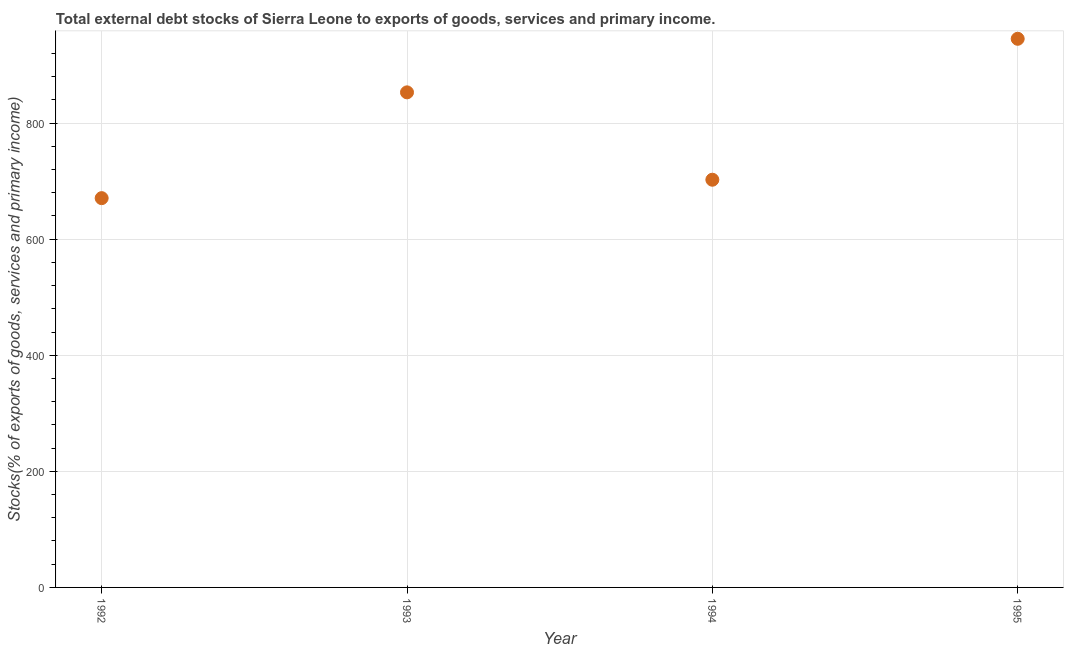What is the external debt stocks in 1994?
Your response must be concise. 702.4. Across all years, what is the maximum external debt stocks?
Your answer should be very brief. 945.21. Across all years, what is the minimum external debt stocks?
Offer a very short reply. 670.67. In which year was the external debt stocks minimum?
Ensure brevity in your answer.  1992. What is the sum of the external debt stocks?
Make the answer very short. 3171.21. What is the difference between the external debt stocks in 1993 and 1995?
Your answer should be compact. -92.28. What is the average external debt stocks per year?
Provide a succinct answer. 792.8. What is the median external debt stocks?
Offer a terse response. 777.66. In how many years, is the external debt stocks greater than 40 %?
Offer a very short reply. 4. Do a majority of the years between 1992 and 1994 (inclusive) have external debt stocks greater than 520 %?
Ensure brevity in your answer.  Yes. What is the ratio of the external debt stocks in 1993 to that in 1994?
Provide a short and direct response. 1.21. Is the difference between the external debt stocks in 1994 and 1995 greater than the difference between any two years?
Your answer should be compact. No. What is the difference between the highest and the second highest external debt stocks?
Provide a short and direct response. 92.28. Is the sum of the external debt stocks in 1992 and 1993 greater than the maximum external debt stocks across all years?
Make the answer very short. Yes. What is the difference between the highest and the lowest external debt stocks?
Your response must be concise. 274.54. In how many years, is the external debt stocks greater than the average external debt stocks taken over all years?
Offer a very short reply. 2. Does the external debt stocks monotonically increase over the years?
Offer a terse response. No. How many dotlines are there?
Provide a succinct answer. 1. What is the difference between two consecutive major ticks on the Y-axis?
Offer a terse response. 200. Does the graph contain any zero values?
Offer a very short reply. No. What is the title of the graph?
Offer a terse response. Total external debt stocks of Sierra Leone to exports of goods, services and primary income. What is the label or title of the X-axis?
Offer a terse response. Year. What is the label or title of the Y-axis?
Provide a short and direct response. Stocks(% of exports of goods, services and primary income). What is the Stocks(% of exports of goods, services and primary income) in 1992?
Your answer should be compact. 670.67. What is the Stocks(% of exports of goods, services and primary income) in 1993?
Provide a succinct answer. 852.93. What is the Stocks(% of exports of goods, services and primary income) in 1994?
Provide a succinct answer. 702.4. What is the Stocks(% of exports of goods, services and primary income) in 1995?
Provide a short and direct response. 945.21. What is the difference between the Stocks(% of exports of goods, services and primary income) in 1992 and 1993?
Keep it short and to the point. -182.26. What is the difference between the Stocks(% of exports of goods, services and primary income) in 1992 and 1994?
Your answer should be compact. -31.73. What is the difference between the Stocks(% of exports of goods, services and primary income) in 1992 and 1995?
Give a very brief answer. -274.54. What is the difference between the Stocks(% of exports of goods, services and primary income) in 1993 and 1994?
Provide a short and direct response. 150.53. What is the difference between the Stocks(% of exports of goods, services and primary income) in 1993 and 1995?
Your answer should be compact. -92.28. What is the difference between the Stocks(% of exports of goods, services and primary income) in 1994 and 1995?
Provide a short and direct response. -242.81. What is the ratio of the Stocks(% of exports of goods, services and primary income) in 1992 to that in 1993?
Give a very brief answer. 0.79. What is the ratio of the Stocks(% of exports of goods, services and primary income) in 1992 to that in 1994?
Keep it short and to the point. 0.95. What is the ratio of the Stocks(% of exports of goods, services and primary income) in 1992 to that in 1995?
Make the answer very short. 0.71. What is the ratio of the Stocks(% of exports of goods, services and primary income) in 1993 to that in 1994?
Provide a succinct answer. 1.21. What is the ratio of the Stocks(% of exports of goods, services and primary income) in 1993 to that in 1995?
Offer a very short reply. 0.9. What is the ratio of the Stocks(% of exports of goods, services and primary income) in 1994 to that in 1995?
Offer a very short reply. 0.74. 